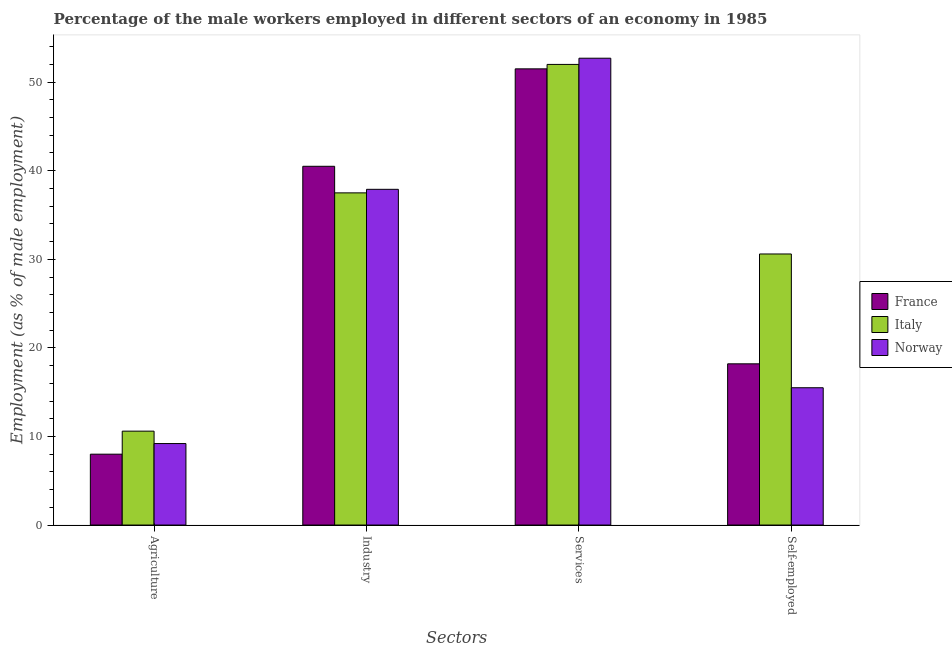How many different coloured bars are there?
Make the answer very short. 3. Are the number of bars on each tick of the X-axis equal?
Provide a short and direct response. Yes. How many bars are there on the 3rd tick from the left?
Offer a terse response. 3. How many bars are there on the 1st tick from the right?
Ensure brevity in your answer.  3. What is the label of the 3rd group of bars from the left?
Ensure brevity in your answer.  Services. What is the percentage of male workers in industry in Norway?
Offer a terse response. 37.9. Across all countries, what is the maximum percentage of male workers in services?
Ensure brevity in your answer.  52.7. Across all countries, what is the minimum percentage of male workers in industry?
Ensure brevity in your answer.  37.5. In which country was the percentage of self employed male workers maximum?
Ensure brevity in your answer.  Italy. In which country was the percentage of self employed male workers minimum?
Ensure brevity in your answer.  Norway. What is the total percentage of self employed male workers in the graph?
Provide a short and direct response. 64.3. What is the difference between the percentage of self employed male workers in France and that in Italy?
Keep it short and to the point. -12.4. What is the difference between the percentage of male workers in agriculture in Italy and the percentage of male workers in industry in France?
Provide a succinct answer. -29.9. What is the average percentage of male workers in services per country?
Offer a terse response. 52.07. What is the difference between the percentage of self employed male workers and percentage of male workers in industry in France?
Provide a short and direct response. -22.3. What is the ratio of the percentage of male workers in services in France to that in Italy?
Ensure brevity in your answer.  0.99. Is the difference between the percentage of male workers in agriculture in Italy and France greater than the difference between the percentage of male workers in industry in Italy and France?
Your response must be concise. Yes. What is the difference between the highest and the second highest percentage of male workers in services?
Keep it short and to the point. 0.7. What is the difference between the highest and the lowest percentage of male workers in services?
Keep it short and to the point. 1.2. In how many countries, is the percentage of male workers in agriculture greater than the average percentage of male workers in agriculture taken over all countries?
Your response must be concise. 1. Is the sum of the percentage of male workers in services in France and Italy greater than the maximum percentage of self employed male workers across all countries?
Provide a succinct answer. Yes. Is it the case that in every country, the sum of the percentage of male workers in services and percentage of self employed male workers is greater than the sum of percentage of male workers in agriculture and percentage of male workers in industry?
Give a very brief answer. No. What does the 3rd bar from the left in Services represents?
Provide a short and direct response. Norway. How many bars are there?
Provide a short and direct response. 12. How many countries are there in the graph?
Give a very brief answer. 3. Are the values on the major ticks of Y-axis written in scientific E-notation?
Make the answer very short. No. Does the graph contain any zero values?
Offer a terse response. No. How many legend labels are there?
Offer a terse response. 3. What is the title of the graph?
Make the answer very short. Percentage of the male workers employed in different sectors of an economy in 1985. Does "Latin America(all income levels)" appear as one of the legend labels in the graph?
Provide a short and direct response. No. What is the label or title of the X-axis?
Offer a very short reply. Sectors. What is the label or title of the Y-axis?
Offer a very short reply. Employment (as % of male employment). What is the Employment (as % of male employment) in Italy in Agriculture?
Your answer should be very brief. 10.6. What is the Employment (as % of male employment) in Norway in Agriculture?
Offer a terse response. 9.2. What is the Employment (as % of male employment) of France in Industry?
Provide a short and direct response. 40.5. What is the Employment (as % of male employment) of Italy in Industry?
Ensure brevity in your answer.  37.5. What is the Employment (as % of male employment) in Norway in Industry?
Your answer should be compact. 37.9. What is the Employment (as % of male employment) in France in Services?
Your response must be concise. 51.5. What is the Employment (as % of male employment) in Norway in Services?
Your answer should be compact. 52.7. What is the Employment (as % of male employment) in France in Self-employed?
Offer a terse response. 18.2. What is the Employment (as % of male employment) of Italy in Self-employed?
Give a very brief answer. 30.6. Across all Sectors, what is the maximum Employment (as % of male employment) in France?
Provide a short and direct response. 51.5. Across all Sectors, what is the maximum Employment (as % of male employment) of Norway?
Provide a short and direct response. 52.7. Across all Sectors, what is the minimum Employment (as % of male employment) of France?
Offer a very short reply. 8. Across all Sectors, what is the minimum Employment (as % of male employment) in Italy?
Your answer should be compact. 10.6. Across all Sectors, what is the minimum Employment (as % of male employment) in Norway?
Your answer should be very brief. 9.2. What is the total Employment (as % of male employment) of France in the graph?
Make the answer very short. 118.2. What is the total Employment (as % of male employment) in Italy in the graph?
Offer a terse response. 130.7. What is the total Employment (as % of male employment) in Norway in the graph?
Offer a terse response. 115.3. What is the difference between the Employment (as % of male employment) of France in Agriculture and that in Industry?
Your answer should be compact. -32.5. What is the difference between the Employment (as % of male employment) in Italy in Agriculture and that in Industry?
Your answer should be compact. -26.9. What is the difference between the Employment (as % of male employment) in Norway in Agriculture and that in Industry?
Provide a short and direct response. -28.7. What is the difference between the Employment (as % of male employment) of France in Agriculture and that in Services?
Offer a very short reply. -43.5. What is the difference between the Employment (as % of male employment) in Italy in Agriculture and that in Services?
Ensure brevity in your answer.  -41.4. What is the difference between the Employment (as % of male employment) of Norway in Agriculture and that in Services?
Provide a succinct answer. -43.5. What is the difference between the Employment (as % of male employment) of Italy in Agriculture and that in Self-employed?
Your answer should be very brief. -20. What is the difference between the Employment (as % of male employment) of Norway in Agriculture and that in Self-employed?
Your answer should be compact. -6.3. What is the difference between the Employment (as % of male employment) in Italy in Industry and that in Services?
Your answer should be compact. -14.5. What is the difference between the Employment (as % of male employment) in Norway in Industry and that in Services?
Ensure brevity in your answer.  -14.8. What is the difference between the Employment (as % of male employment) in France in Industry and that in Self-employed?
Offer a terse response. 22.3. What is the difference between the Employment (as % of male employment) of Italy in Industry and that in Self-employed?
Ensure brevity in your answer.  6.9. What is the difference between the Employment (as % of male employment) in Norway in Industry and that in Self-employed?
Your answer should be compact. 22.4. What is the difference between the Employment (as % of male employment) in France in Services and that in Self-employed?
Ensure brevity in your answer.  33.3. What is the difference between the Employment (as % of male employment) in Italy in Services and that in Self-employed?
Offer a very short reply. 21.4. What is the difference between the Employment (as % of male employment) in Norway in Services and that in Self-employed?
Offer a terse response. 37.2. What is the difference between the Employment (as % of male employment) in France in Agriculture and the Employment (as % of male employment) in Italy in Industry?
Make the answer very short. -29.5. What is the difference between the Employment (as % of male employment) in France in Agriculture and the Employment (as % of male employment) in Norway in Industry?
Ensure brevity in your answer.  -29.9. What is the difference between the Employment (as % of male employment) in Italy in Agriculture and the Employment (as % of male employment) in Norway in Industry?
Your answer should be compact. -27.3. What is the difference between the Employment (as % of male employment) in France in Agriculture and the Employment (as % of male employment) in Italy in Services?
Make the answer very short. -44. What is the difference between the Employment (as % of male employment) of France in Agriculture and the Employment (as % of male employment) of Norway in Services?
Your response must be concise. -44.7. What is the difference between the Employment (as % of male employment) in Italy in Agriculture and the Employment (as % of male employment) in Norway in Services?
Your answer should be compact. -42.1. What is the difference between the Employment (as % of male employment) of France in Agriculture and the Employment (as % of male employment) of Italy in Self-employed?
Your response must be concise. -22.6. What is the difference between the Employment (as % of male employment) of France in Agriculture and the Employment (as % of male employment) of Norway in Self-employed?
Your response must be concise. -7.5. What is the difference between the Employment (as % of male employment) in Italy in Agriculture and the Employment (as % of male employment) in Norway in Self-employed?
Keep it short and to the point. -4.9. What is the difference between the Employment (as % of male employment) in France in Industry and the Employment (as % of male employment) in Norway in Services?
Your answer should be compact. -12.2. What is the difference between the Employment (as % of male employment) in Italy in Industry and the Employment (as % of male employment) in Norway in Services?
Provide a short and direct response. -15.2. What is the difference between the Employment (as % of male employment) in France in Industry and the Employment (as % of male employment) in Italy in Self-employed?
Make the answer very short. 9.9. What is the difference between the Employment (as % of male employment) of France in Industry and the Employment (as % of male employment) of Norway in Self-employed?
Give a very brief answer. 25. What is the difference between the Employment (as % of male employment) of Italy in Industry and the Employment (as % of male employment) of Norway in Self-employed?
Offer a terse response. 22. What is the difference between the Employment (as % of male employment) of France in Services and the Employment (as % of male employment) of Italy in Self-employed?
Offer a very short reply. 20.9. What is the difference between the Employment (as % of male employment) in France in Services and the Employment (as % of male employment) in Norway in Self-employed?
Keep it short and to the point. 36. What is the difference between the Employment (as % of male employment) of Italy in Services and the Employment (as % of male employment) of Norway in Self-employed?
Provide a succinct answer. 36.5. What is the average Employment (as % of male employment) in France per Sectors?
Offer a terse response. 29.55. What is the average Employment (as % of male employment) in Italy per Sectors?
Offer a terse response. 32.67. What is the average Employment (as % of male employment) of Norway per Sectors?
Your response must be concise. 28.82. What is the difference between the Employment (as % of male employment) of Italy and Employment (as % of male employment) of Norway in Agriculture?
Offer a terse response. 1.4. What is the difference between the Employment (as % of male employment) of France and Employment (as % of male employment) of Norway in Industry?
Your answer should be very brief. 2.6. What is the difference between the Employment (as % of male employment) of Italy and Employment (as % of male employment) of Norway in Industry?
Provide a short and direct response. -0.4. What is the difference between the Employment (as % of male employment) in Italy and Employment (as % of male employment) in Norway in Services?
Make the answer very short. -0.7. What is the difference between the Employment (as % of male employment) in Italy and Employment (as % of male employment) in Norway in Self-employed?
Offer a very short reply. 15.1. What is the ratio of the Employment (as % of male employment) in France in Agriculture to that in Industry?
Offer a terse response. 0.2. What is the ratio of the Employment (as % of male employment) in Italy in Agriculture to that in Industry?
Provide a short and direct response. 0.28. What is the ratio of the Employment (as % of male employment) in Norway in Agriculture to that in Industry?
Your response must be concise. 0.24. What is the ratio of the Employment (as % of male employment) in France in Agriculture to that in Services?
Give a very brief answer. 0.16. What is the ratio of the Employment (as % of male employment) of Italy in Agriculture to that in Services?
Your answer should be very brief. 0.2. What is the ratio of the Employment (as % of male employment) in Norway in Agriculture to that in Services?
Your answer should be compact. 0.17. What is the ratio of the Employment (as % of male employment) in France in Agriculture to that in Self-employed?
Make the answer very short. 0.44. What is the ratio of the Employment (as % of male employment) in Italy in Agriculture to that in Self-employed?
Offer a terse response. 0.35. What is the ratio of the Employment (as % of male employment) of Norway in Agriculture to that in Self-employed?
Provide a short and direct response. 0.59. What is the ratio of the Employment (as % of male employment) in France in Industry to that in Services?
Keep it short and to the point. 0.79. What is the ratio of the Employment (as % of male employment) of Italy in Industry to that in Services?
Your response must be concise. 0.72. What is the ratio of the Employment (as % of male employment) in Norway in Industry to that in Services?
Provide a short and direct response. 0.72. What is the ratio of the Employment (as % of male employment) of France in Industry to that in Self-employed?
Ensure brevity in your answer.  2.23. What is the ratio of the Employment (as % of male employment) of Italy in Industry to that in Self-employed?
Give a very brief answer. 1.23. What is the ratio of the Employment (as % of male employment) of Norway in Industry to that in Self-employed?
Make the answer very short. 2.45. What is the ratio of the Employment (as % of male employment) in France in Services to that in Self-employed?
Make the answer very short. 2.83. What is the ratio of the Employment (as % of male employment) of Italy in Services to that in Self-employed?
Offer a terse response. 1.7. What is the ratio of the Employment (as % of male employment) in Norway in Services to that in Self-employed?
Offer a terse response. 3.4. What is the difference between the highest and the lowest Employment (as % of male employment) in France?
Ensure brevity in your answer.  43.5. What is the difference between the highest and the lowest Employment (as % of male employment) in Italy?
Offer a terse response. 41.4. What is the difference between the highest and the lowest Employment (as % of male employment) of Norway?
Offer a very short reply. 43.5. 